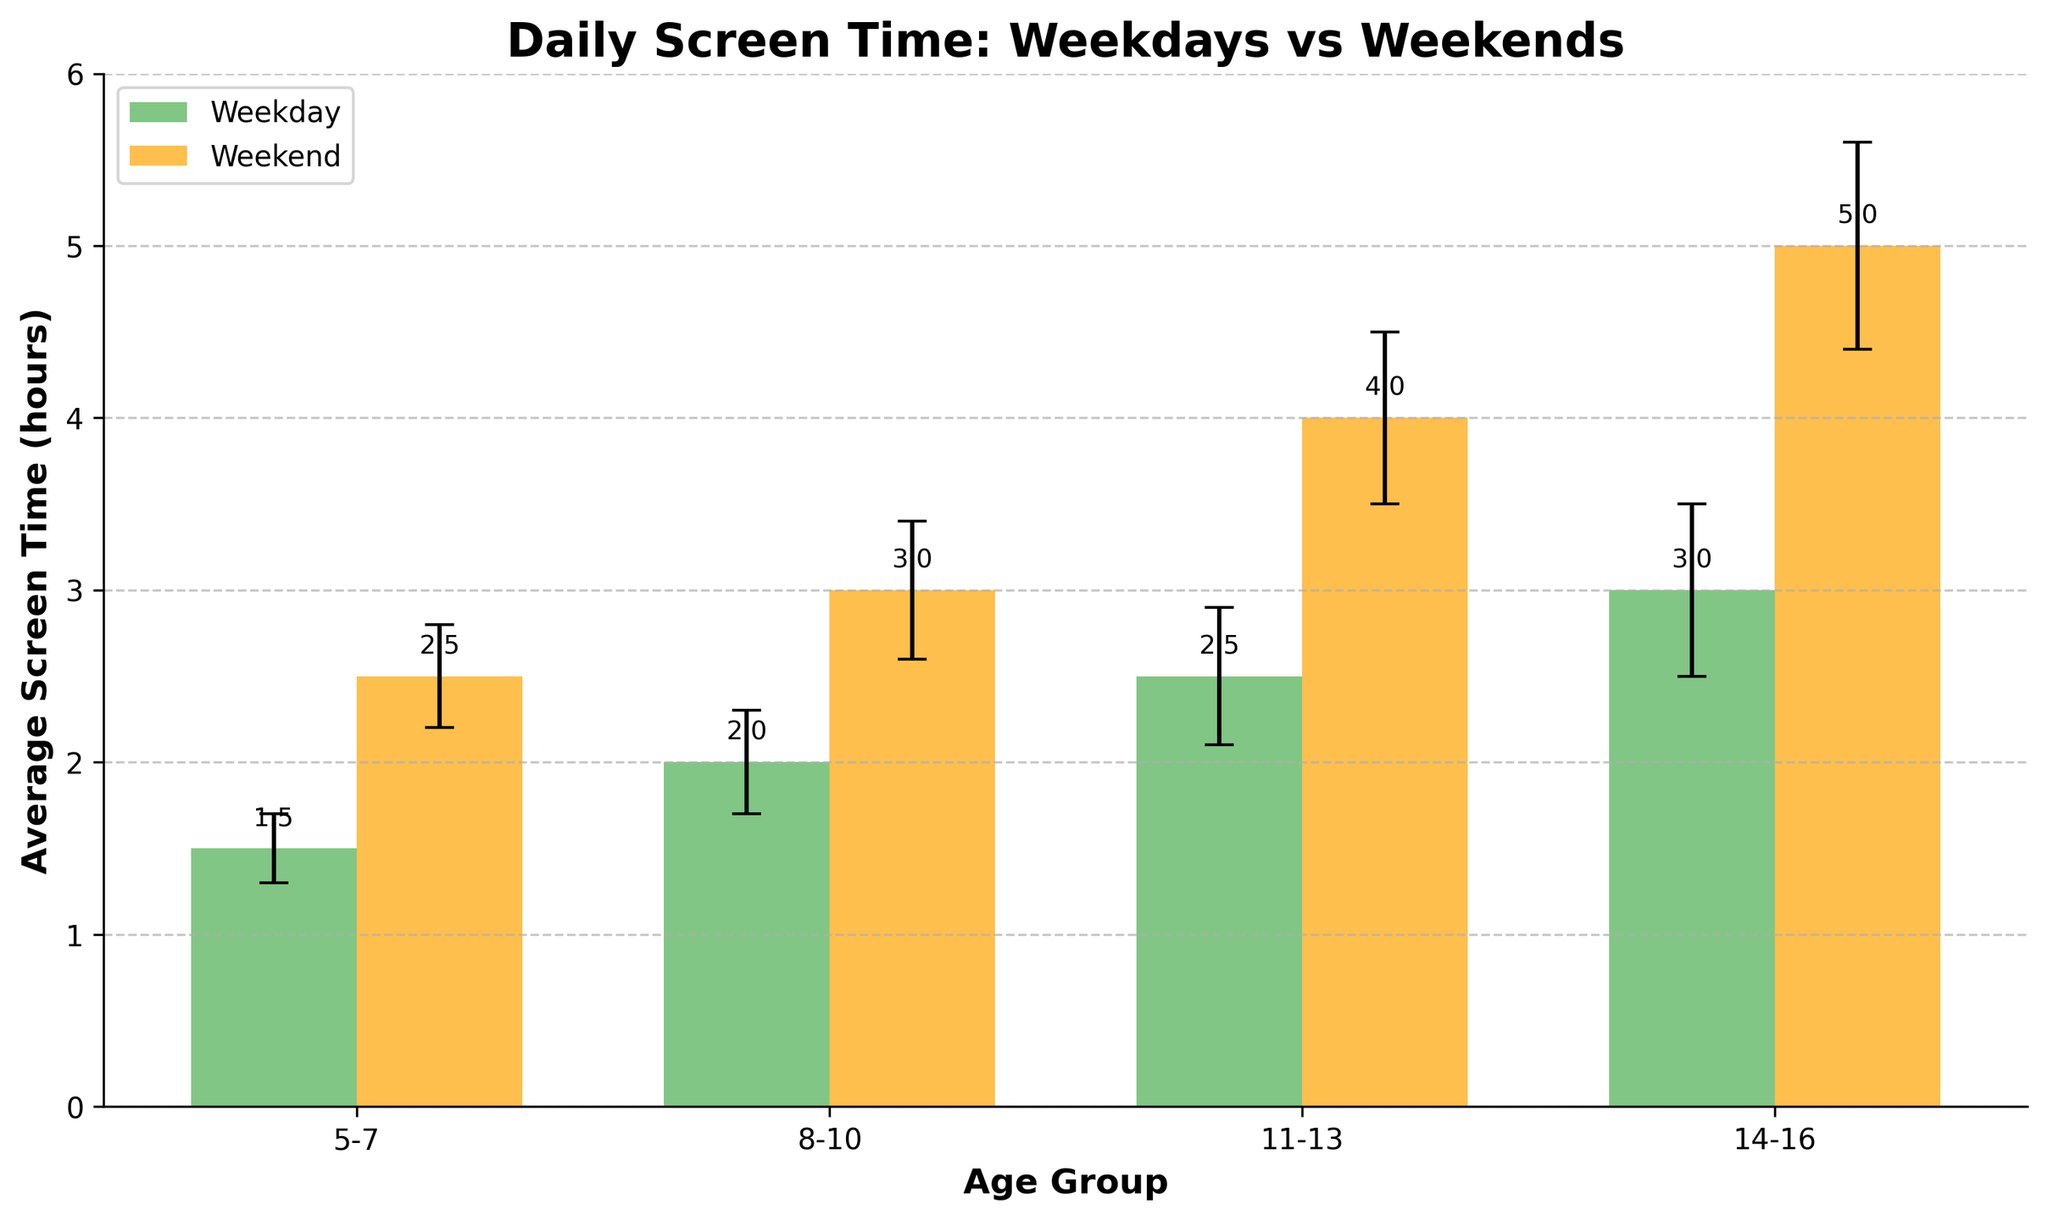What is the title of the figure? The title is typically found at the top of the figure. Here, it states "Daily Screen Time: Weekdays vs Weekends".
Answer: Daily Screen Time: Weekdays vs Weekends Which day has higher average screen time for the 11-13 age group? The figure shows the bars for weekends and weekdays for each age group. The weekend bar is higher than the weekday bar for the 11-13 age group.
Answer: Weekend How many age groups are compared in the figure? The x-axis labels represent the different age groups compared in the figure. There are four age groups: 5-7, 8-10, 11-13, and 14-16.
Answer: 4 What are the error bar values for the 5-7 age group on both days? The error bar values are provided next to each bar. For the 5-7 age group, the weekday error is 0.2 and the weekend error is 0.3.
Answer: Weekday: 0.2, Weekend: 0.3 By how many hours does the screen time increase from weekdays to weekends for the 14-16 age group? The average screen times for 14-16 are 3.0 hours on weekdays and 5.0 hours on weekends. The increase is 5.0 - 3.0 hours.
Answer: 2.0 hours Which age group shows the smallest increase in screen time from weekdays to weekends? To find this, compare the difference between weekday and weekend average screen times for each age group. The 5-7 age group has the smallest difference: 2.5 - 1.5 = 1.0 hours.
Answer: 5-7 What is the average screen time on weekends for the 8-10 age group? The weekend average screen time for the 8-10 age group is displayed on the weekend bar. It is 3.0 hours.
Answer: 3.0 hours Which age group has the highest average screen time on weekdays? Compare the heights of the weekday bars for each age group. The 14-16 age group has the highest average screen time at 3.0 hours.
Answer: 14-16 Does the screen time always increase from weekdays to weekends across all age groups? Observe the heights of the bars for each age group. For each age group, the weekend bar is higher than the weekday bar, indicating an increase in screen time.
Answer: Yes 